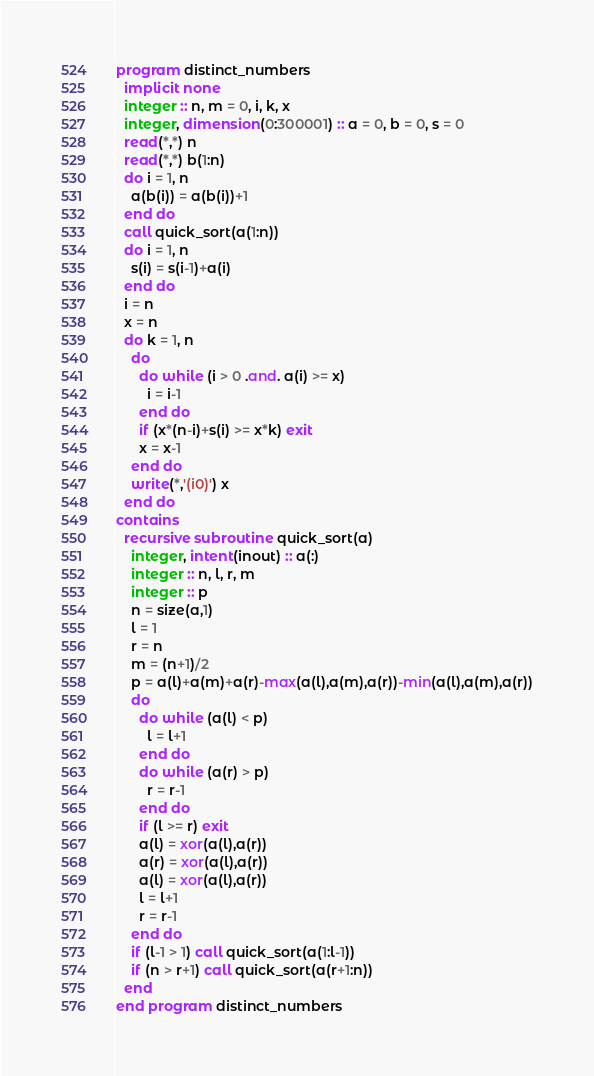<code> <loc_0><loc_0><loc_500><loc_500><_FORTRAN_>program distinct_numbers
  implicit none
  integer :: n, m = 0, i, k, x
  integer, dimension(0:300001) :: a = 0, b = 0, s = 0
  read(*,*) n
  read(*,*) b(1:n)
  do i = 1, n
    a(b(i)) = a(b(i))+1
  end do
  call quick_sort(a(1:n))
  do i = 1, n
    s(i) = s(i-1)+a(i)
  end do
  i = n
  x = n
  do k = 1, n
    do
      do while (i > 0 .and. a(i) >= x)
        i = i-1
      end do
      if (x*(n-i)+s(i) >= x*k) exit
      x = x-1
    end do
    write(*,'(i0)') x
  end do
contains
  recursive subroutine quick_sort(a)
    integer, intent(inout) :: a(:)
    integer :: n, l, r, m
    integer :: p
    n = size(a,1)
    l = 1
    r = n
    m = (n+1)/2
    p = a(l)+a(m)+a(r)-max(a(l),a(m),a(r))-min(a(l),a(m),a(r))
    do
      do while (a(l) < p)
        l = l+1
      end do
      do while (a(r) > p)
        r = r-1
      end do
      if (l >= r) exit
      a(l) = xor(a(l),a(r))
      a(r) = xor(a(l),a(r))
      a(l) = xor(a(l),a(r))
      l = l+1
      r = r-1
    end do
    if (l-1 > 1) call quick_sort(a(1:l-1))
    if (n > r+1) call quick_sort(a(r+1:n))
  end
end program distinct_numbers</code> 